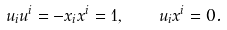<formula> <loc_0><loc_0><loc_500><loc_500>u _ { i } u ^ { i } = - x _ { i } x ^ { i } = 1 , \quad u _ { i } x ^ { i } = 0 .</formula> 